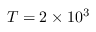Convert formula to latex. <formula><loc_0><loc_0><loc_500><loc_500>T = 2 \times 1 0 ^ { 3 }</formula> 